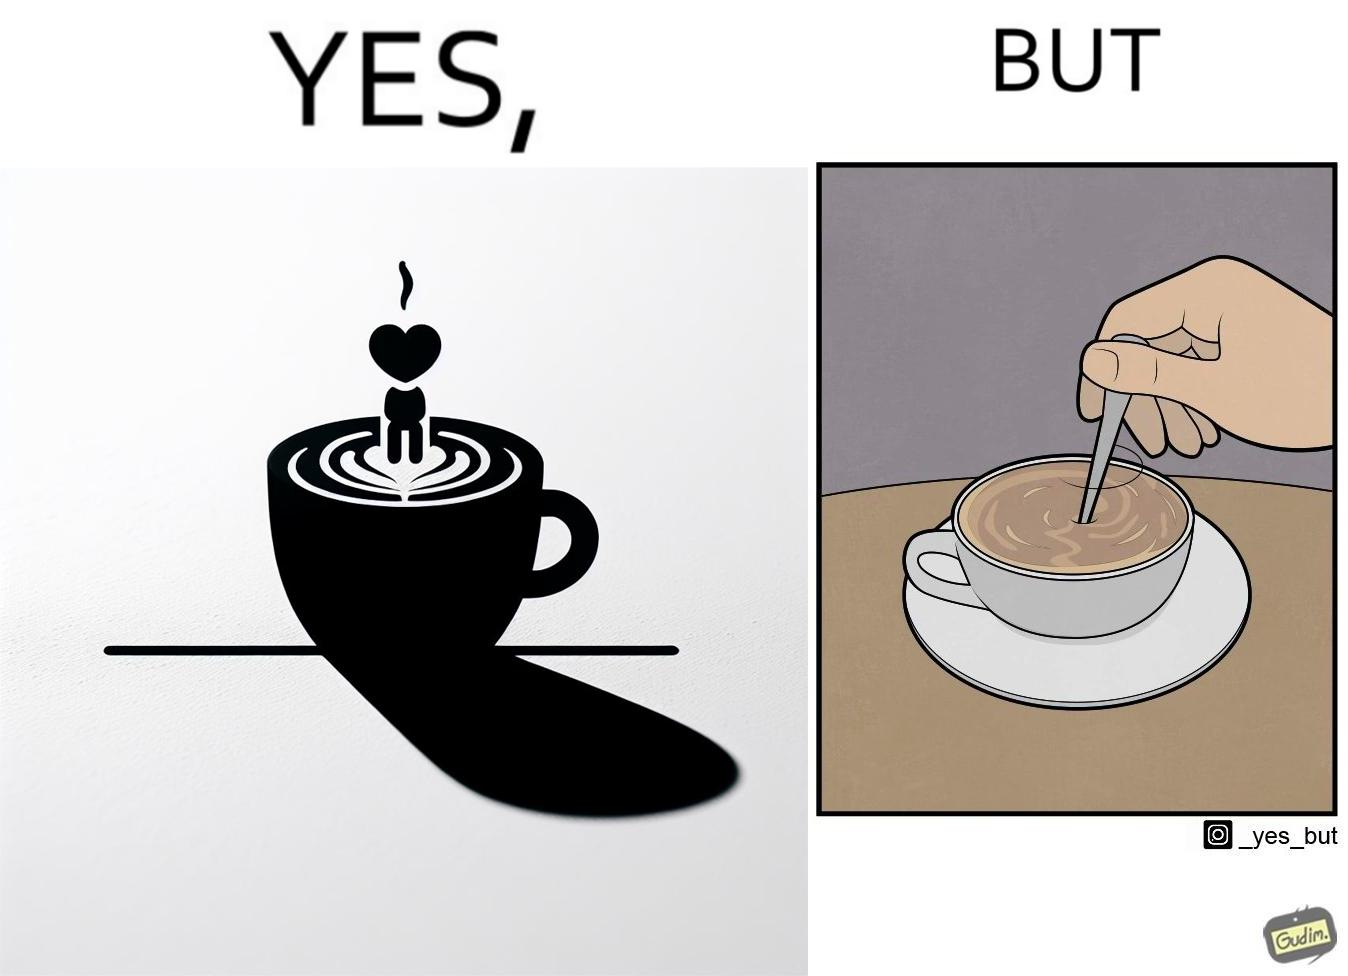Describe the content of this image. The image is ironic, because even when the coffee maker create latte art to make coffee look attractive but it is there just for a short time after that it is vanished 